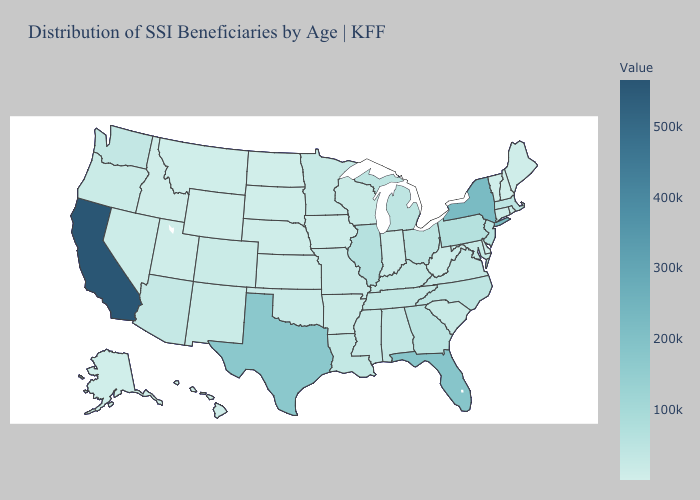Which states have the lowest value in the USA?
Answer briefly. Wyoming. Does Washington have the highest value in the West?
Write a very short answer. No. Which states have the highest value in the USA?
Keep it brief. California. Does North Carolina have a lower value than Florida?
Quick response, please. Yes. Among the states that border Pennsylvania , which have the highest value?
Quick response, please. New York. Among the states that border New Mexico , which have the lowest value?
Answer briefly. Utah. 